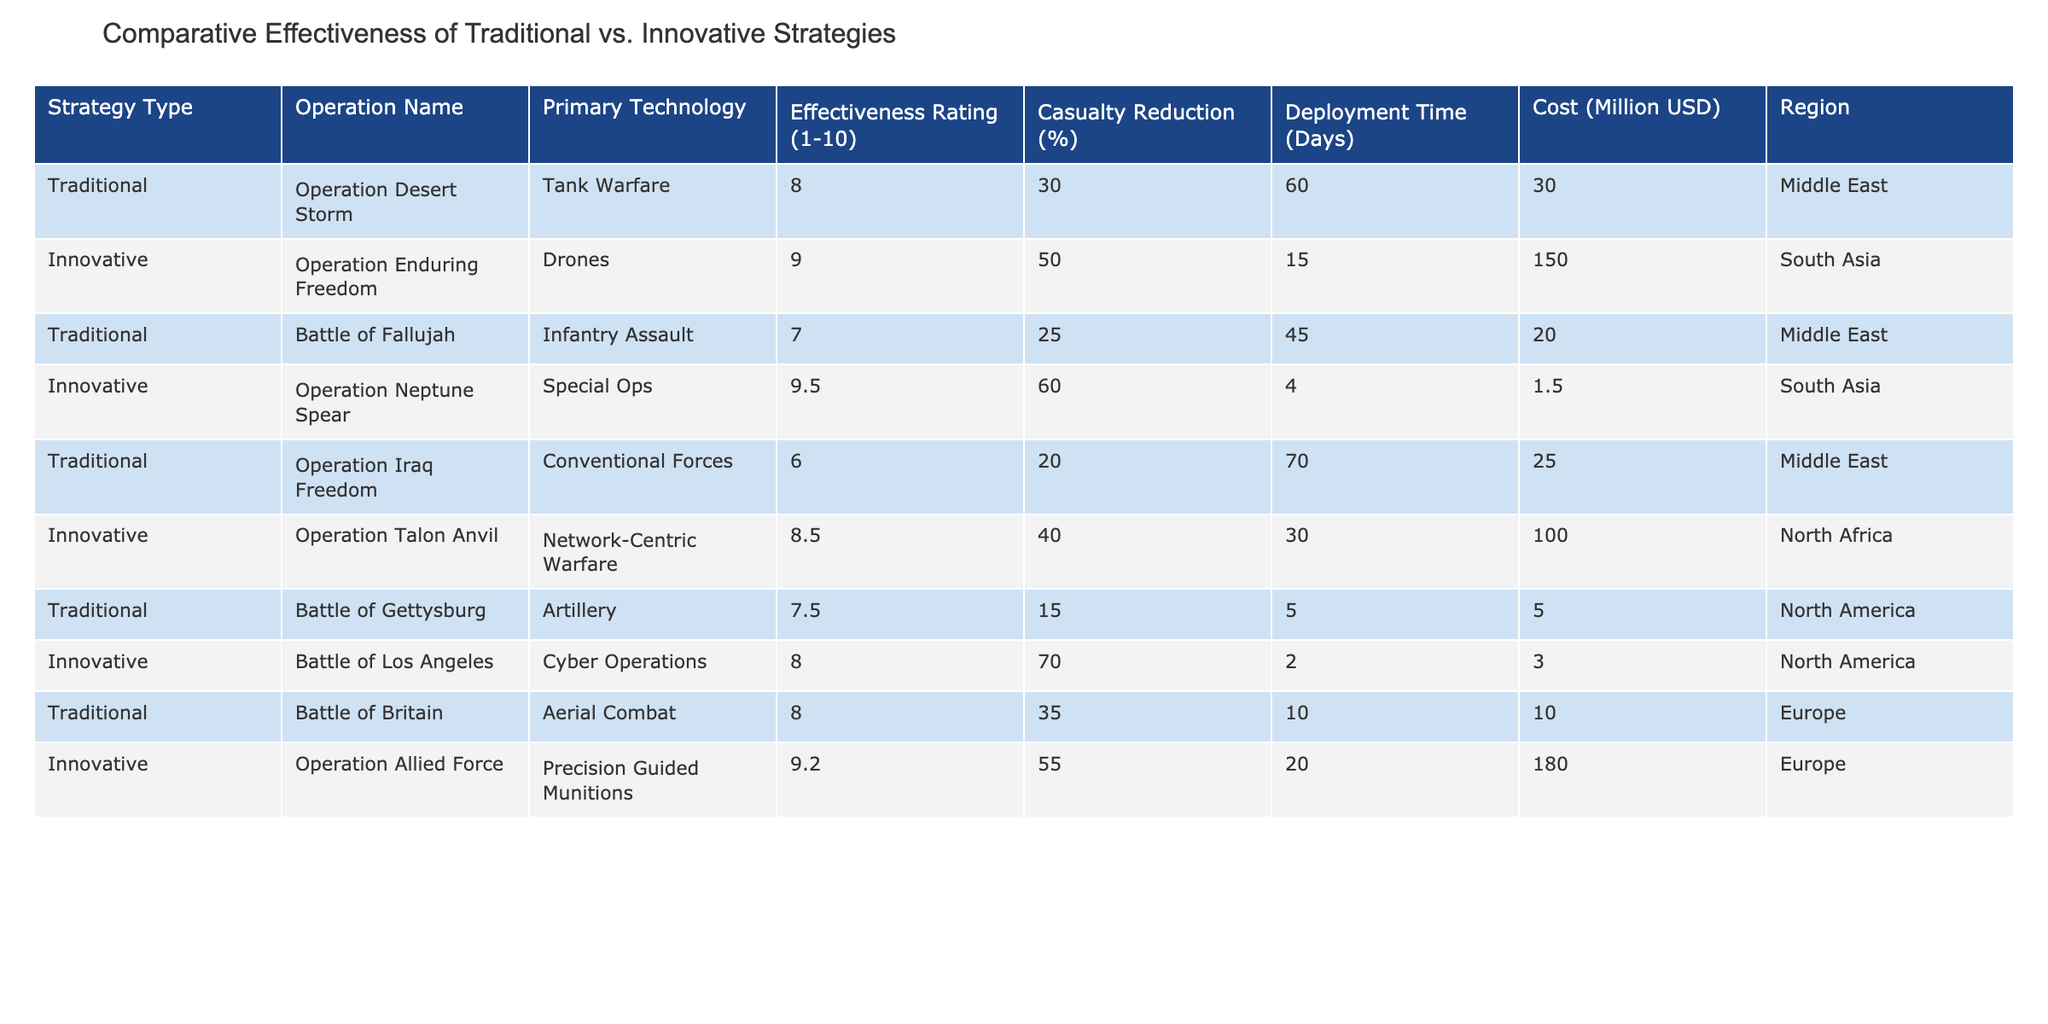What is the effectiveness rating of Operation Neptune Spear? The effectiveness rating is explicitly listed under the column "Effectiveness Rating (1-10)" for this operation in the table. It shows a value of 9.5.
Answer: 9.5 Which operation has the highest casualty reduction percentage? By comparing the "Casualty Reduction (%)" column, the operation with the highest value is "Battle of Los Angeles," which shows a reduction of 70%.
Answer: 70% What is the average deployment time for innovative strategies? The deployment times for the innovative strategies are 15, 4, 30, and 2 days. To find the average, sum these values: 15 + 4 + 30 + 2 = 51. Then, divide by the number of innovative operations (4): 51 / 4 = 12.75.
Answer: 12.75 Did Operation Iraq Freedom have a higher effectiveness rating than Operation Talon Anvil? Looking at the "Effectiveness Rating (1-10)" of both operations, Operation Iraq Freedom has a rating of 6 and Operation Talon Anvil has a rating of 8.5. Since 6 is less than 8.5, the statement is false.
Answer: No What is the total cost of all operations listed in the table? To get the total cost, sum the values from the "Cost (Million USD)" column. This is calculated as follows: 30 + 150 + 20 + 1.5 + 25 + 100 + 5 + 3 + 10 + 180 = 515.5 million USD.
Answer: 515.5 Is the effectiveness rating of traditional strategies generally lower than that of innovative strategies? To answer this, we compare the average effectiveness ratings. Traditional strategies have ratings of 8, 7, 6, 7.5, and 8, which sum to 36, and the average is 36 / 5 = 7.2. Innovative strategies have ratings of 9, 9.5, 8.5, 8, and 9.2, which sum to 44.2, averaging 44.2 / 5 = 8.84. Since 7.2 is lower than 8.84, the statement is true.
Answer: Yes What is the difference in deployment time between Operation Desert Storm and Operation Enduring Freedom? The deployment time for Operation Desert Storm is 60 days and for Operation Enduring Freedom is 15 days. To find the difference, subtract 15 from 60: 60 - 15 = 45 days.
Answer: 45 Which operation is associated with the use of cyber operations? The operation related to cyber operations is "Battle of Los Angeles," as indicated in the "Primary Technology" column.
Answer: Battle of Los Angeles What percentage of casualty reduction is associated with Operation Allied Force? The casualty reduction percentage for Operation Allied Force is listed in the table under the respective column and shows a value of 55%.
Answer: 55% 